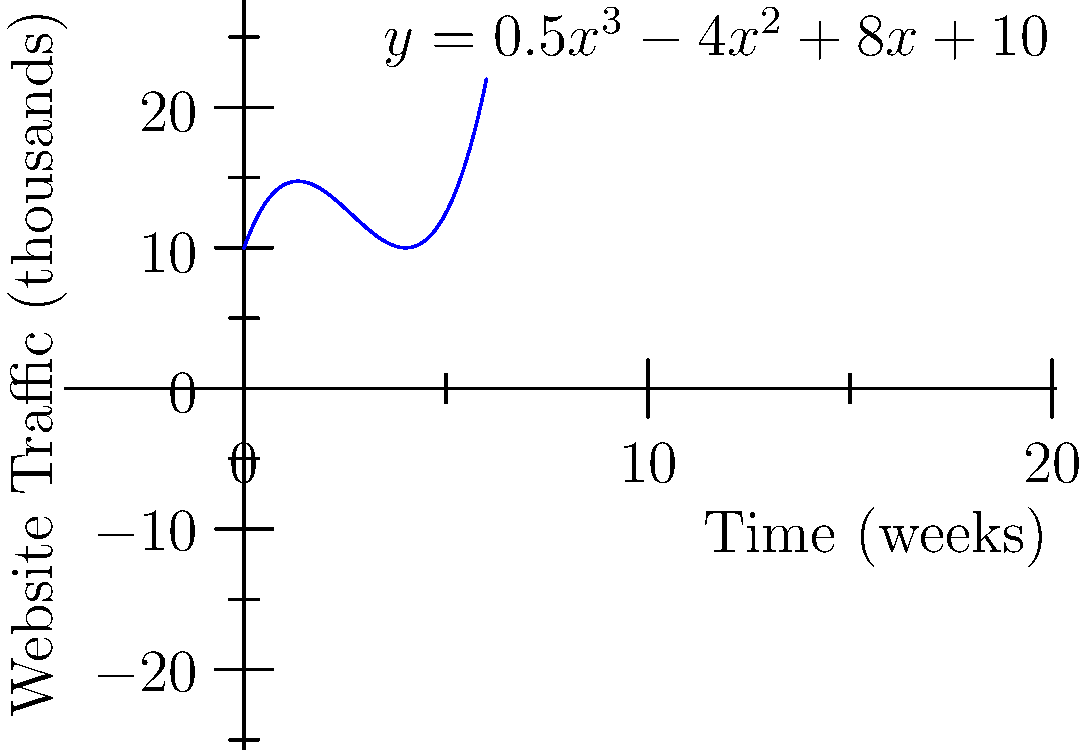A digital marketing campaign's impact on website traffic is modeled by the polynomial function $y = 0.5x^3 - 4x^2 + 8x + 10$, where $y$ represents website traffic in thousands and $x$ represents time in weeks. After how many weeks will the website traffic reach its minimum during the first 6 weeks of the campaign? To find the minimum point of the function within the given interval, we need to follow these steps:

1) First, we need to find the derivative of the function:
   $f'(x) = 1.5x^2 - 8x + 8$

2) Set the derivative equal to zero to find critical points:
   $1.5x^2 - 8x + 8 = 0$

3) Solve this quadratic equation:
   $1.5(x^2 - \frac{16}{3}x + \frac{16}{3}) = 0$
   $1.5(x - \frac{8}{3})(x - 2) = 0$
   $x = \frac{8}{3}$ or $x = 2$

4) The second derivative is $f''(x) = 3x - 8$. At $x = 2$, $f''(2) = -2 < 0$, indicating a local maximum.
   At $x = \frac{8}{3}$, $f''(\frac{8}{3}) = 2 > 0$, indicating a local minimum.

5) Since $\frac{8}{3} \approx 2.67$ is within our interval of 0 to 6 weeks, this is our answer.

Therefore, the website traffic will reach its minimum after approximately 2.67 weeks.
Answer: 2.67 weeks 